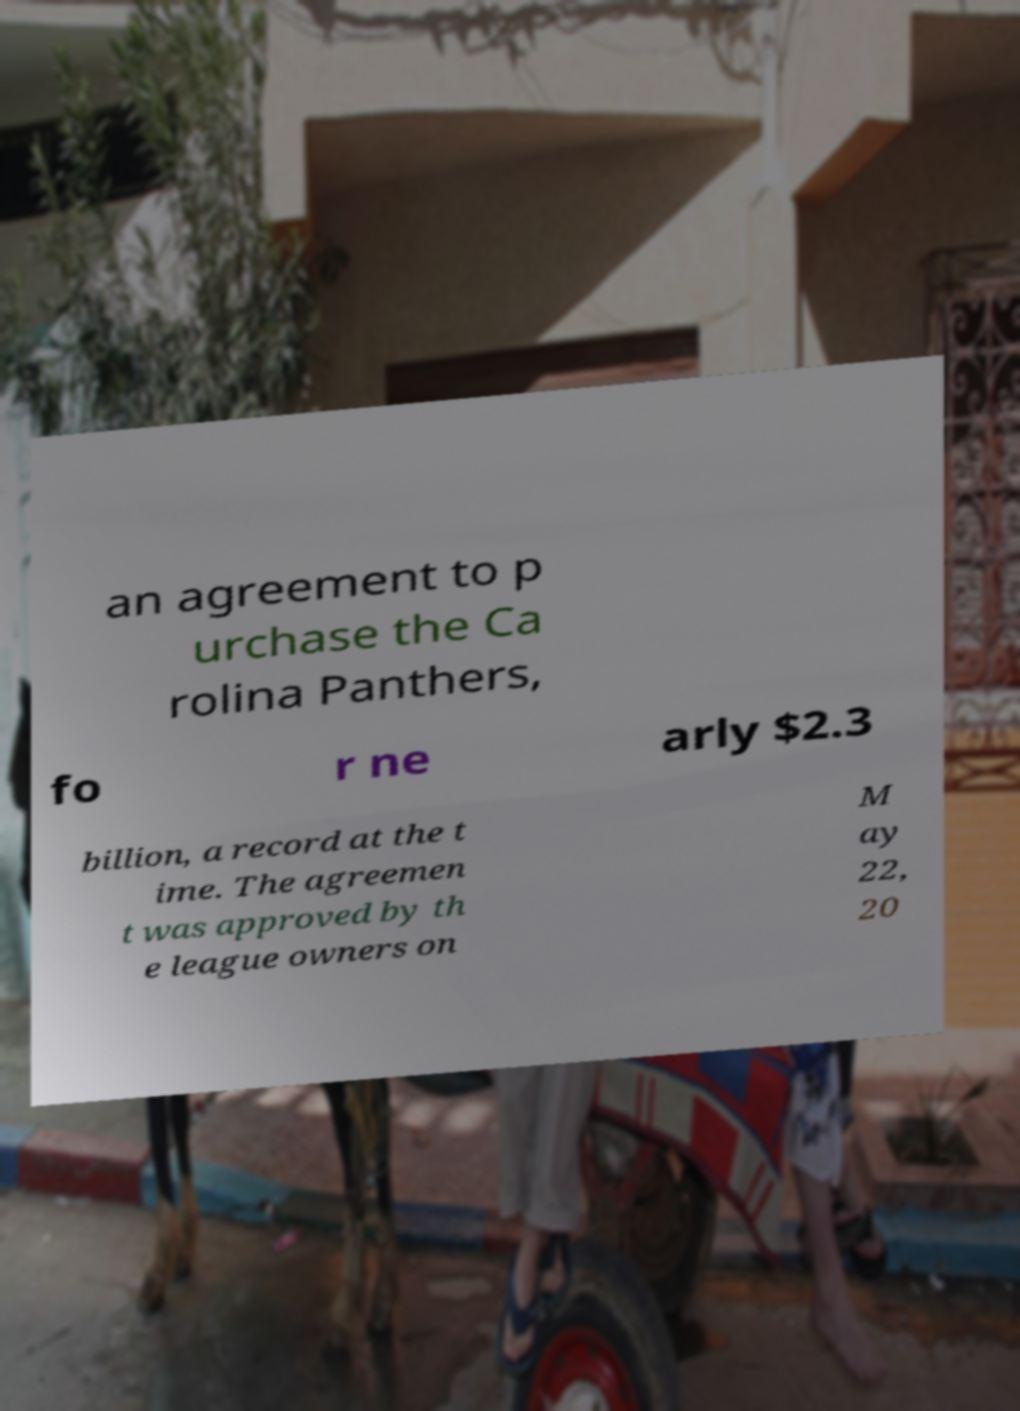What messages or text are displayed in this image? I need them in a readable, typed format. an agreement to p urchase the Ca rolina Panthers, fo r ne arly $2.3 billion, a record at the t ime. The agreemen t was approved by th e league owners on M ay 22, 20 